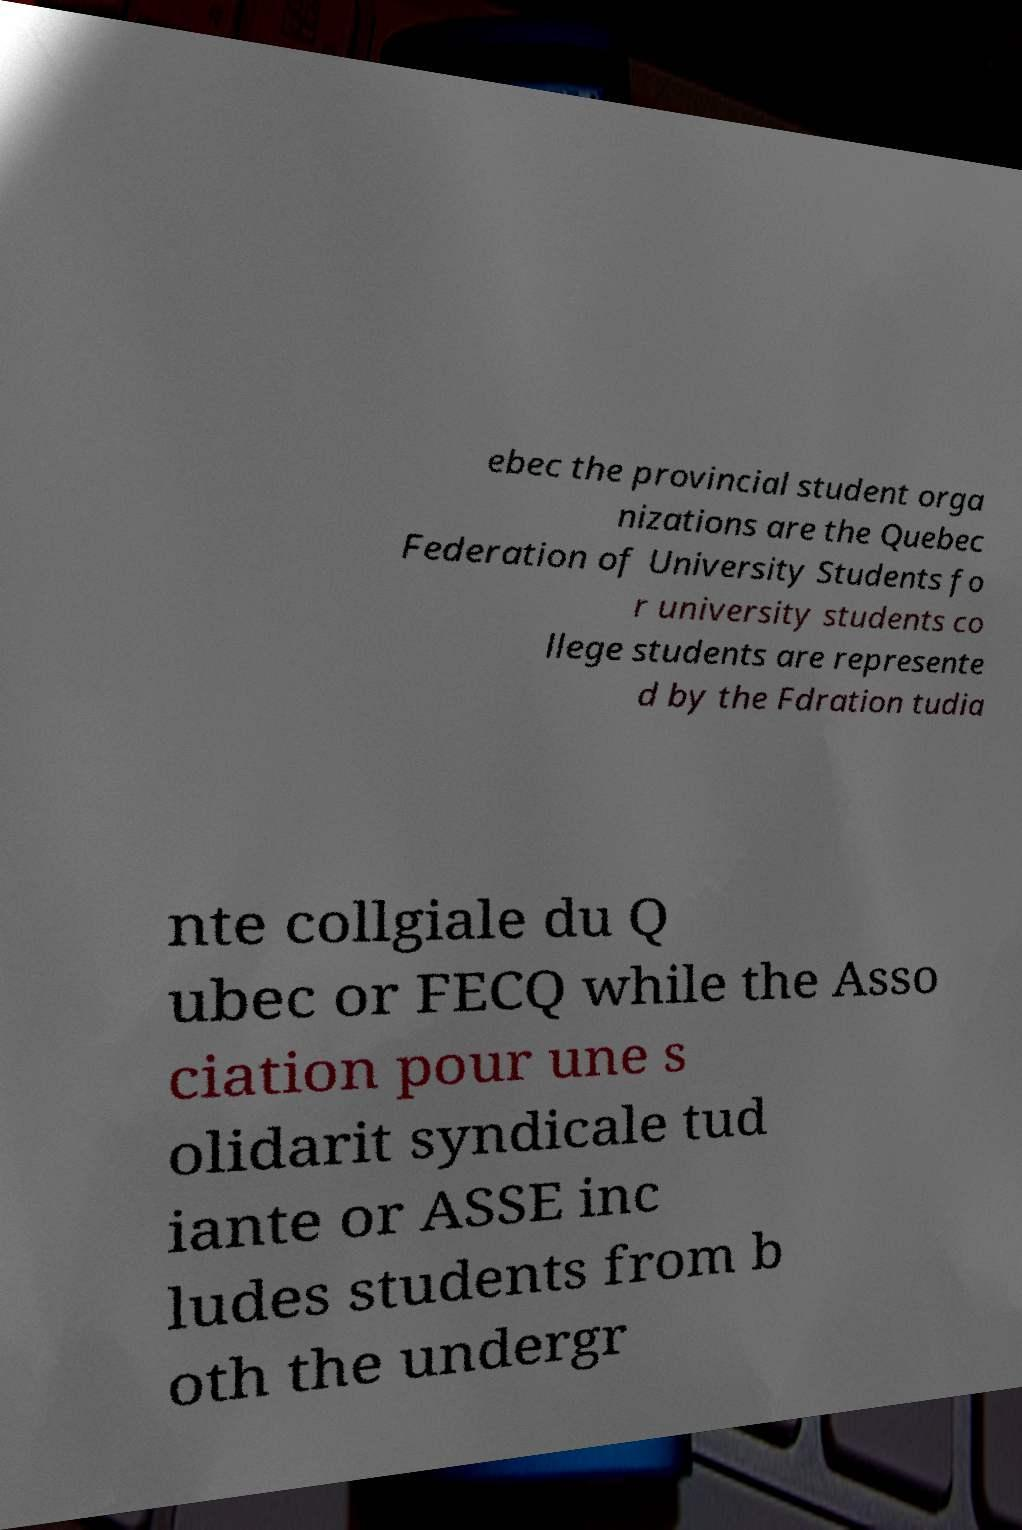What messages or text are displayed in this image? I need them in a readable, typed format. ebec the provincial student orga nizations are the Quebec Federation of University Students fo r university students co llege students are represente d by the Fdration tudia nte collgiale du Q ubec or FECQ while the Asso ciation pour une s olidarit syndicale tud iante or ASSE inc ludes students from b oth the undergr 